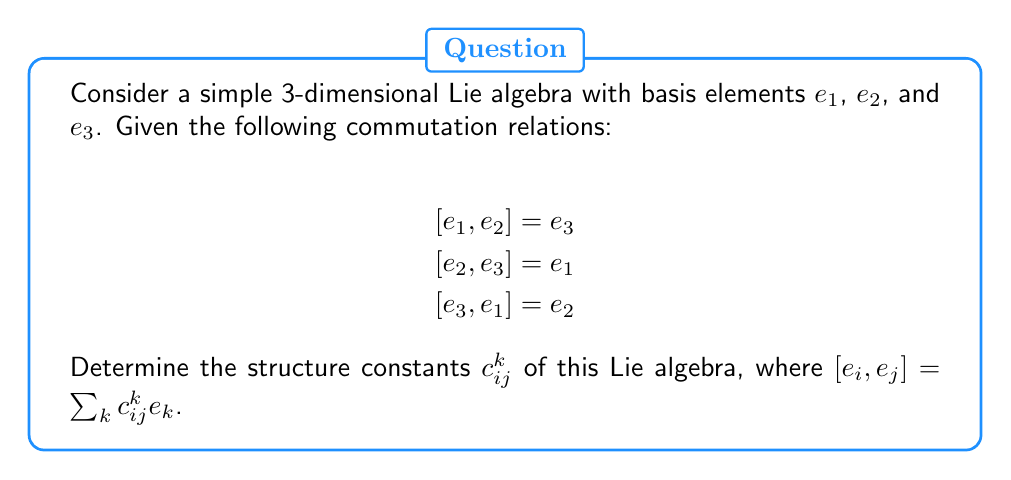Show me your answer to this math problem. To determine the structure constants of this Lie algebra, we need to follow these steps:

1. Recall that for a Lie algebra with basis elements $e_i$, the structure constants $c_{ij}^k$ are defined by the equation:

   $$[e_i, e_j] = \sum_k c_{ij}^k e_k$$

2. Compare the given commutation relations with this general form:

   $$[e_1, e_2] = e_3 \implies c_{12}^3 = 1, \text{ all other } c_{12}^k = 0$$
   $$[e_2, e_3] = e_1 \implies c_{23}^1 = 1, \text{ all other } c_{23}^k = 0$$
   $$[e_3, e_1] = e_2 \implies c_{31}^2 = 1, \text{ all other } c_{31}^k = 0$$

3. Note that the structure constants are antisymmetric in the lower indices:

   $$c_{ij}^k = -c_{ji}^k$$

   This means:
   $$c_{21}^3 = -1, c_{32}^1 = -1, c_{13}^2 = -1$$

4. All other structure constants not mentioned above are zero.

5. We can summarize the non-zero structure constants as:

   $$c_{12}^3 = c_{23}^1 = c_{31}^2 = 1$$
   $$c_{21}^3 = c_{32}^1 = c_{13}^2 = -1$$

These structure constants fully define the Lie algebra and its commutation relations.
Answer: The non-zero structure constants of the given Lie algebra are:

$$c_{12}^3 = c_{23}^1 = c_{31}^2 = 1$$
$$c_{21}^3 = c_{32}^1 = c_{13}^2 = -1$$

All other structure constants are zero. 